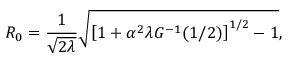Convert formula to latex. <formula><loc_0><loc_0><loc_500><loc_500>R _ { 0 } = \frac { 1 } { \sqrt { 2 \lambda } } \sqrt { \left [ 1 + \alpha ^ { 2 } \lambda G ^ { - 1 } ( 1 / 2 ) \right ] ^ { 1 / 2 } - 1 } ,</formula> 